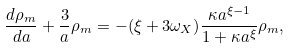Convert formula to latex. <formula><loc_0><loc_0><loc_500><loc_500>\frac { d \rho _ { m } } { d a } + \frac { 3 } { a } \rho _ { m } = - ( \xi + 3 \omega _ { X } ) \frac { \kappa a ^ { \xi - 1 } } { 1 + \kappa a ^ { \xi } } \rho _ { m } ,</formula> 